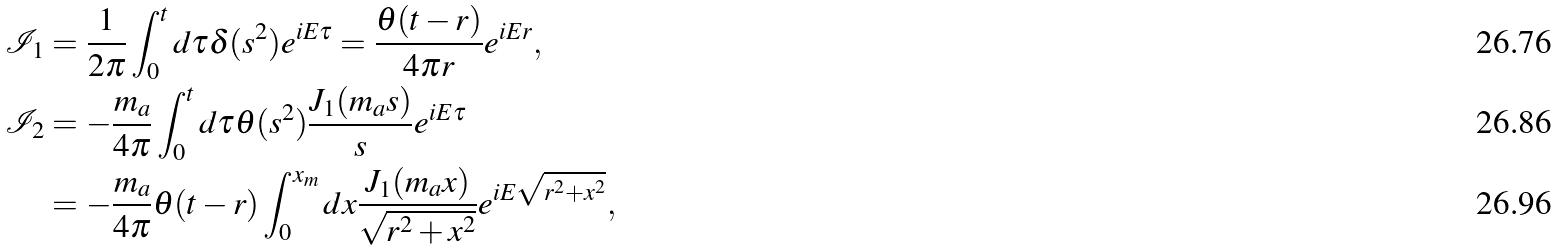Convert formula to latex. <formula><loc_0><loc_0><loc_500><loc_500>\mathcal { I } _ { 1 } & = \frac { 1 } { 2 \pi } \int _ { 0 } ^ { t } d \tau \delta ( s ^ { 2 } ) e ^ { i E \tau } = \frac { \theta ( t - r ) } { 4 \pi r } e ^ { i E r } , \\ \mathcal { I } _ { 2 } & = - \frac { m _ { a } } { 4 \pi } \int _ { 0 } ^ { t } d \tau \theta ( s ^ { 2 } ) \frac { J _ { 1 } ( m _ { a } s ) } { s } e ^ { i E \tau } \\ & = - \frac { m _ { a } } { 4 \pi } \theta ( t - r ) \int _ { 0 } ^ { x _ { m } } d x \frac { J _ { 1 } ( m _ { a } x ) } { \sqrt { r ^ { 2 } + x ^ { 2 } } } e ^ { i E \sqrt { r ^ { 2 } + x ^ { 2 } } } ,</formula> 